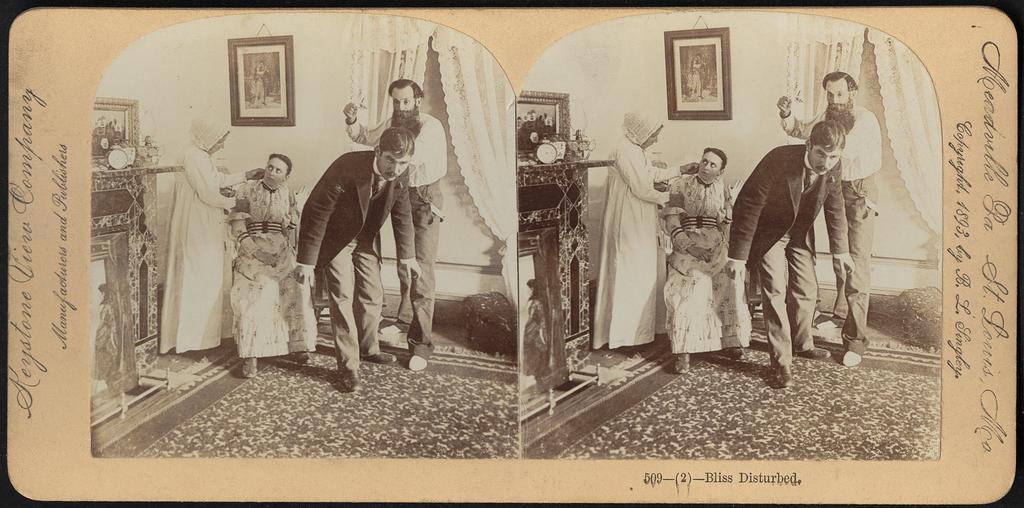Please provide a concise description of this image. In this image we can see two black and white pictures. To the both sides of the image text is written. 